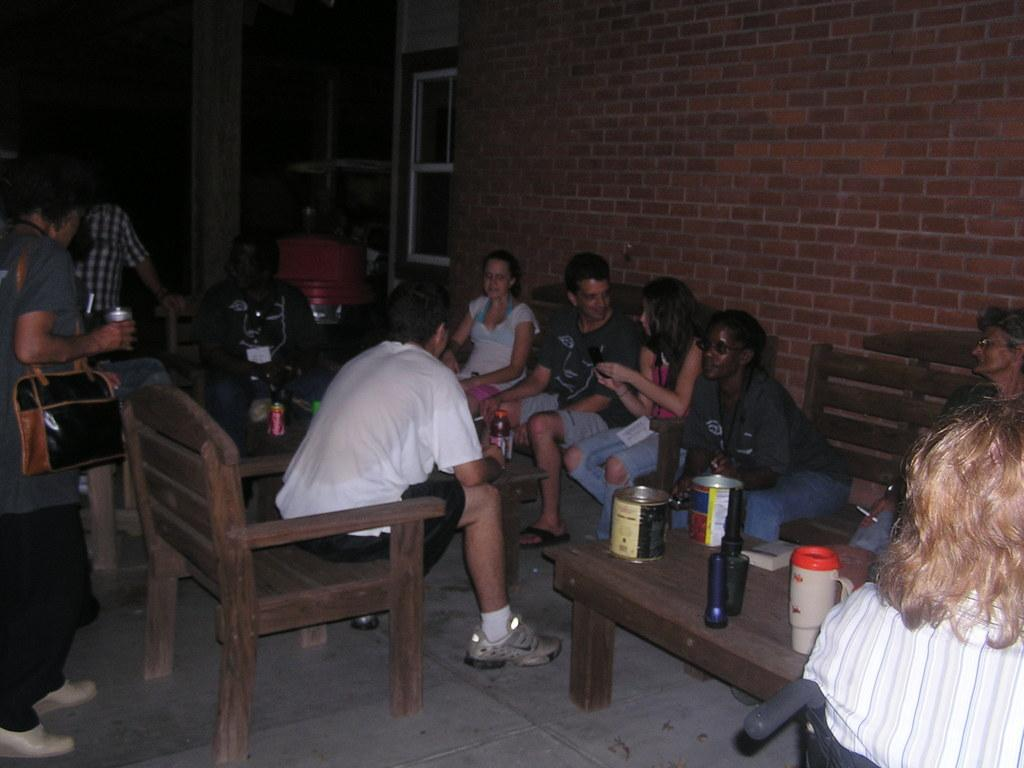How many people are in the image? There is a group of people in the image. What are the people doing in the image? The people are sitting on chairs. What is in front of the chairs? There is a table in front of the chairs. What items can be seen on the table? There is a bottle and a glass on the table. What can be seen in the background of the image? There is a wall and a closed window in the background of the image. What type of cannon is visible in the image? There is no cannon present in the image. What is the name of the downtown street where the scene takes place? The image does not provide information about the location being downtown, nor does it mention any street names. 